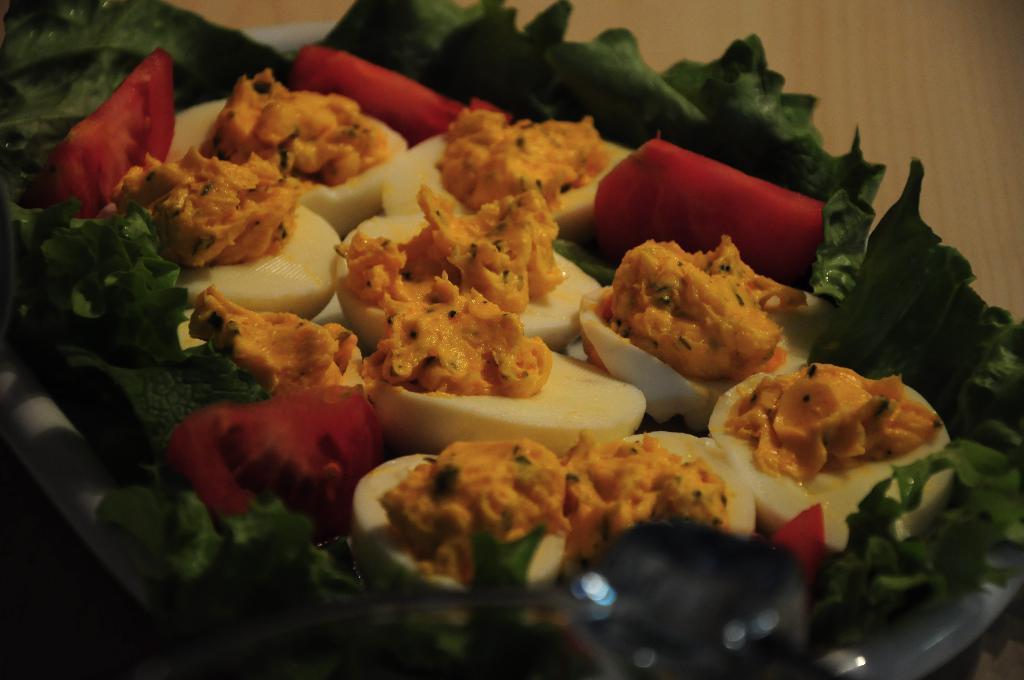In one or two sentences, can you explain what this image depicts? In this image we can see some food item. 